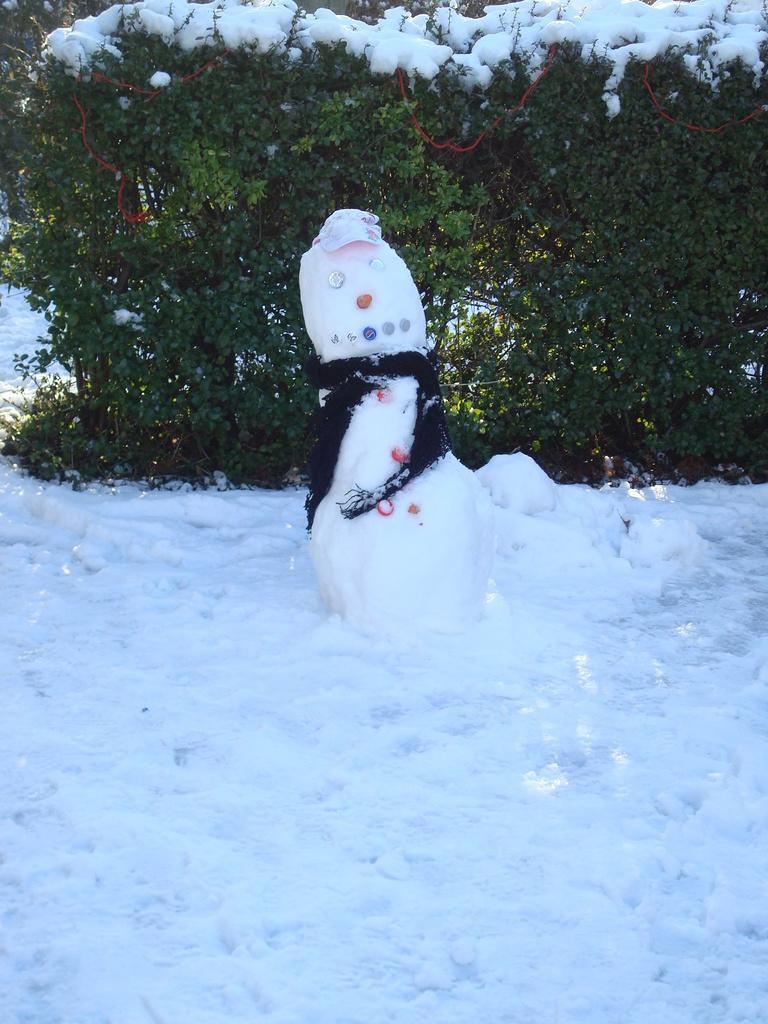Can you describe this image briefly? In this image we can see few plants. There is a snow in the image. There is a snow doll in the image. 